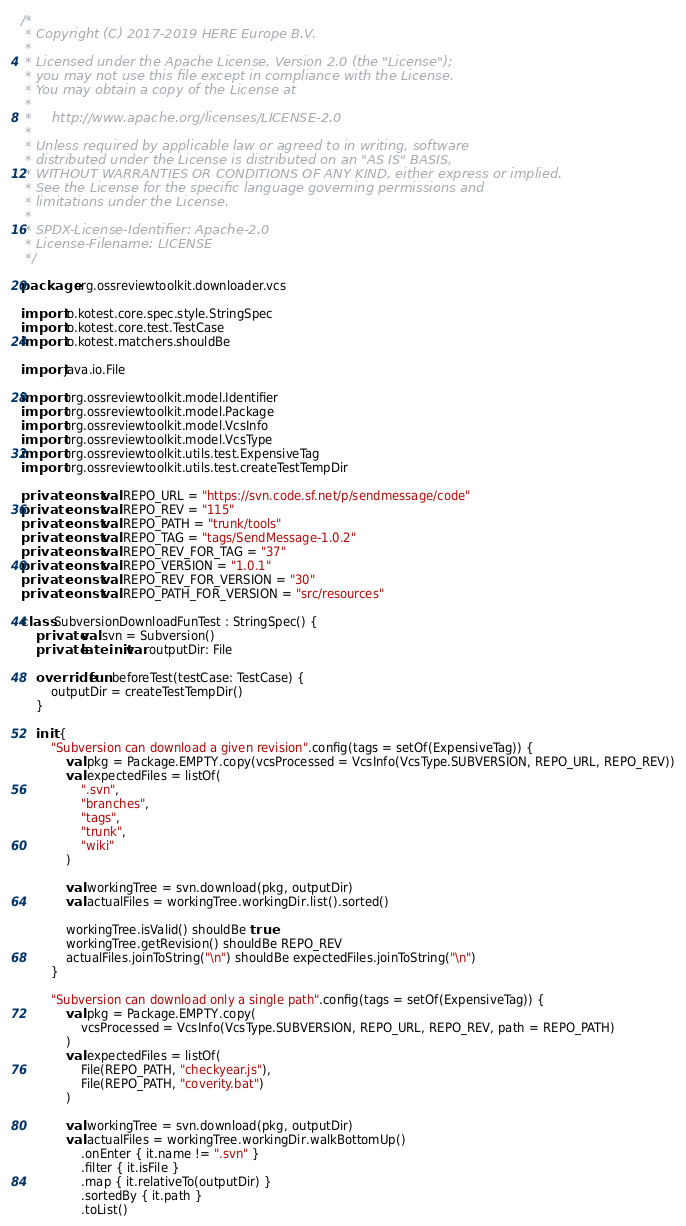Convert code to text. <code><loc_0><loc_0><loc_500><loc_500><_Kotlin_>/*
 * Copyright (C) 2017-2019 HERE Europe B.V.
 *
 * Licensed under the Apache License, Version 2.0 (the "License");
 * you may not use this file except in compliance with the License.
 * You may obtain a copy of the License at
 *
 *     http://www.apache.org/licenses/LICENSE-2.0
 *
 * Unless required by applicable law or agreed to in writing, software
 * distributed under the License is distributed on an "AS IS" BASIS,
 * WITHOUT WARRANTIES OR CONDITIONS OF ANY KIND, either express or implied.
 * See the License for the specific language governing permissions and
 * limitations under the License.
 *
 * SPDX-License-Identifier: Apache-2.0
 * License-Filename: LICENSE
 */

package org.ossreviewtoolkit.downloader.vcs

import io.kotest.core.spec.style.StringSpec
import io.kotest.core.test.TestCase
import io.kotest.matchers.shouldBe

import java.io.File

import org.ossreviewtoolkit.model.Identifier
import org.ossreviewtoolkit.model.Package
import org.ossreviewtoolkit.model.VcsInfo
import org.ossreviewtoolkit.model.VcsType
import org.ossreviewtoolkit.utils.test.ExpensiveTag
import org.ossreviewtoolkit.utils.test.createTestTempDir

private const val REPO_URL = "https://svn.code.sf.net/p/sendmessage/code"
private const val REPO_REV = "115"
private const val REPO_PATH = "trunk/tools"
private const val REPO_TAG = "tags/SendMessage-1.0.2"
private const val REPO_REV_FOR_TAG = "37"
private const val REPO_VERSION = "1.0.1"
private const val REPO_REV_FOR_VERSION = "30"
private const val REPO_PATH_FOR_VERSION = "src/resources"

class SubversionDownloadFunTest : StringSpec() {
    private val svn = Subversion()
    private lateinit var outputDir: File

    override fun beforeTest(testCase: TestCase) {
        outputDir = createTestTempDir()
    }

    init {
        "Subversion can download a given revision".config(tags = setOf(ExpensiveTag)) {
            val pkg = Package.EMPTY.copy(vcsProcessed = VcsInfo(VcsType.SUBVERSION, REPO_URL, REPO_REV))
            val expectedFiles = listOf(
                ".svn",
                "branches",
                "tags",
                "trunk",
                "wiki"
            )

            val workingTree = svn.download(pkg, outputDir)
            val actualFiles = workingTree.workingDir.list().sorted()

            workingTree.isValid() shouldBe true
            workingTree.getRevision() shouldBe REPO_REV
            actualFiles.joinToString("\n") shouldBe expectedFiles.joinToString("\n")
        }

        "Subversion can download only a single path".config(tags = setOf(ExpensiveTag)) {
            val pkg = Package.EMPTY.copy(
                vcsProcessed = VcsInfo(VcsType.SUBVERSION, REPO_URL, REPO_REV, path = REPO_PATH)
            )
            val expectedFiles = listOf(
                File(REPO_PATH, "checkyear.js"),
                File(REPO_PATH, "coverity.bat")
            )

            val workingTree = svn.download(pkg, outputDir)
            val actualFiles = workingTree.workingDir.walkBottomUp()
                .onEnter { it.name != ".svn" }
                .filter { it.isFile }
                .map { it.relativeTo(outputDir) }
                .sortedBy { it.path }
                .toList()
</code> 